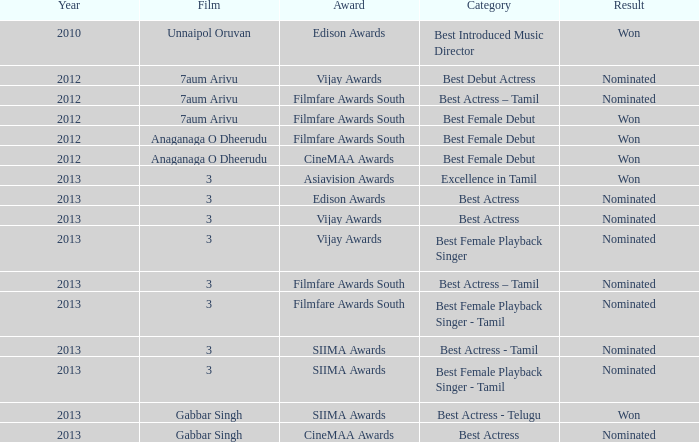What was the consequence related to the film awards and gabbar singh film? Nominated. 